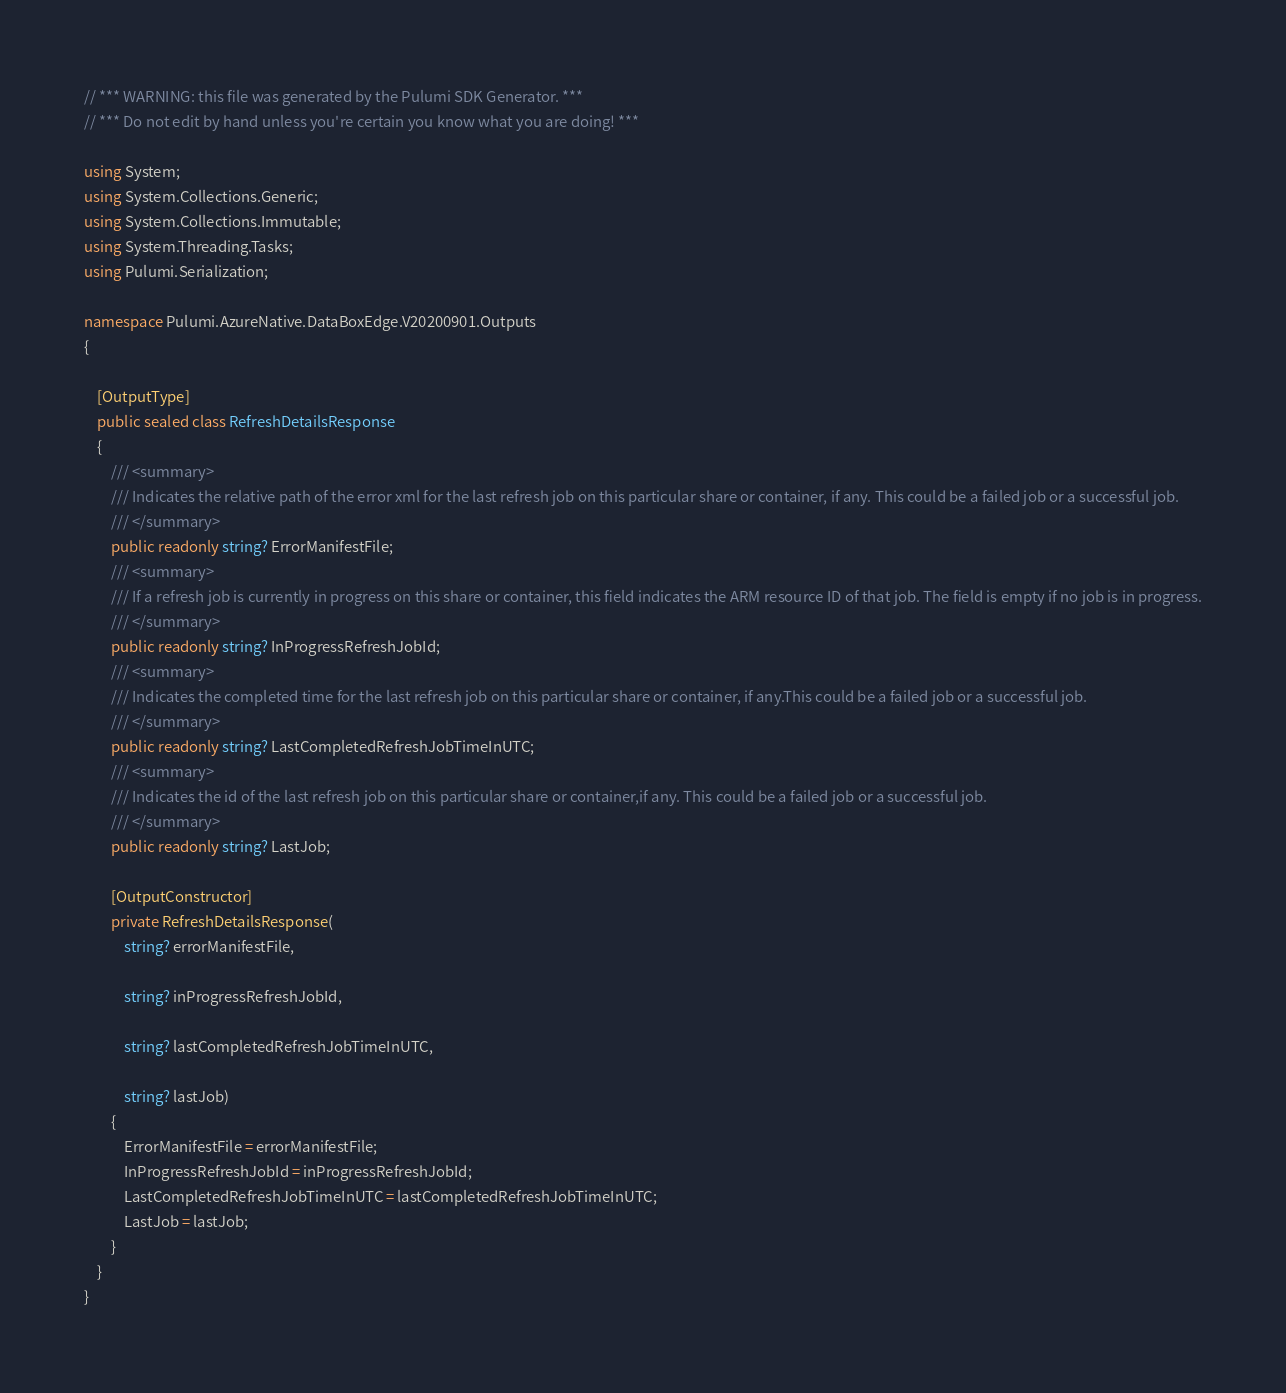<code> <loc_0><loc_0><loc_500><loc_500><_C#_>// *** WARNING: this file was generated by the Pulumi SDK Generator. ***
// *** Do not edit by hand unless you're certain you know what you are doing! ***

using System;
using System.Collections.Generic;
using System.Collections.Immutable;
using System.Threading.Tasks;
using Pulumi.Serialization;

namespace Pulumi.AzureNative.DataBoxEdge.V20200901.Outputs
{

    [OutputType]
    public sealed class RefreshDetailsResponse
    {
        /// <summary>
        /// Indicates the relative path of the error xml for the last refresh job on this particular share or container, if any. This could be a failed job or a successful job.
        /// </summary>
        public readonly string? ErrorManifestFile;
        /// <summary>
        /// If a refresh job is currently in progress on this share or container, this field indicates the ARM resource ID of that job. The field is empty if no job is in progress.
        /// </summary>
        public readonly string? InProgressRefreshJobId;
        /// <summary>
        /// Indicates the completed time for the last refresh job on this particular share or container, if any.This could be a failed job or a successful job.
        /// </summary>
        public readonly string? LastCompletedRefreshJobTimeInUTC;
        /// <summary>
        /// Indicates the id of the last refresh job on this particular share or container,if any. This could be a failed job or a successful job.
        /// </summary>
        public readonly string? LastJob;

        [OutputConstructor]
        private RefreshDetailsResponse(
            string? errorManifestFile,

            string? inProgressRefreshJobId,

            string? lastCompletedRefreshJobTimeInUTC,

            string? lastJob)
        {
            ErrorManifestFile = errorManifestFile;
            InProgressRefreshJobId = inProgressRefreshJobId;
            LastCompletedRefreshJobTimeInUTC = lastCompletedRefreshJobTimeInUTC;
            LastJob = lastJob;
        }
    }
}
</code> 